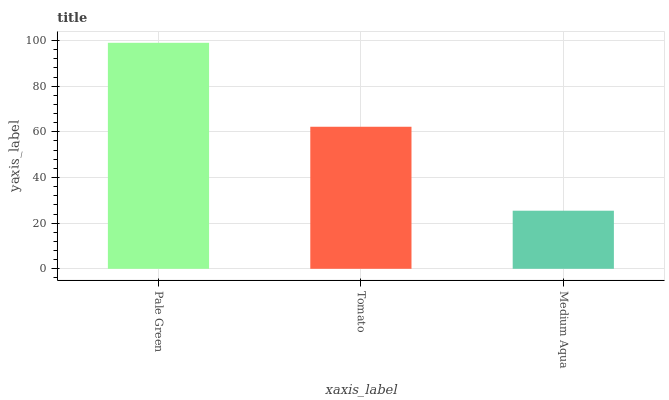Is Medium Aqua the minimum?
Answer yes or no. Yes. Is Pale Green the maximum?
Answer yes or no. Yes. Is Tomato the minimum?
Answer yes or no. No. Is Tomato the maximum?
Answer yes or no. No. Is Pale Green greater than Tomato?
Answer yes or no. Yes. Is Tomato less than Pale Green?
Answer yes or no. Yes. Is Tomato greater than Pale Green?
Answer yes or no. No. Is Pale Green less than Tomato?
Answer yes or no. No. Is Tomato the high median?
Answer yes or no. Yes. Is Tomato the low median?
Answer yes or no. Yes. Is Pale Green the high median?
Answer yes or no. No. Is Pale Green the low median?
Answer yes or no. No. 